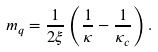Convert formula to latex. <formula><loc_0><loc_0><loc_500><loc_500>m _ { q } = \frac { 1 } { 2 \xi } \left ( \frac { 1 } { \kappa } - \frac { 1 } { \kappa _ { c } } \right ) .</formula> 